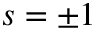Convert formula to latex. <formula><loc_0><loc_0><loc_500><loc_500>s = \pm 1</formula> 